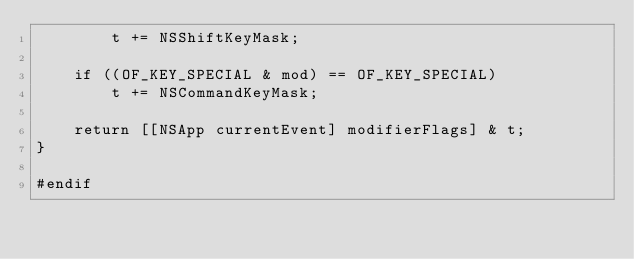Convert code to text. <code><loc_0><loc_0><loc_500><loc_500><_ObjectiveC_>		t += NSShiftKeyMask;

	if ((OF_KEY_SPECIAL & mod) == OF_KEY_SPECIAL)
		t += NSCommandKeyMask;

	return [[NSApp currentEvent] modifierFlags] & t;
}

#endif</code> 